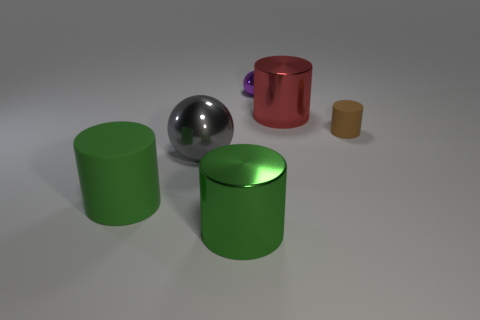Subtract all small brown cylinders. How many cylinders are left? 3 Subtract all red cylinders. How many cylinders are left? 3 Add 2 big matte cylinders. How many objects exist? 8 Subtract all yellow cylinders. Subtract all red balls. How many cylinders are left? 4 Subtract all cylinders. How many objects are left? 2 Add 1 tiny red blocks. How many tiny red blocks exist? 1 Subtract 0 brown balls. How many objects are left? 6 Subtract all gray spheres. Subtract all big red metal cylinders. How many objects are left? 4 Add 1 big red objects. How many big red objects are left? 2 